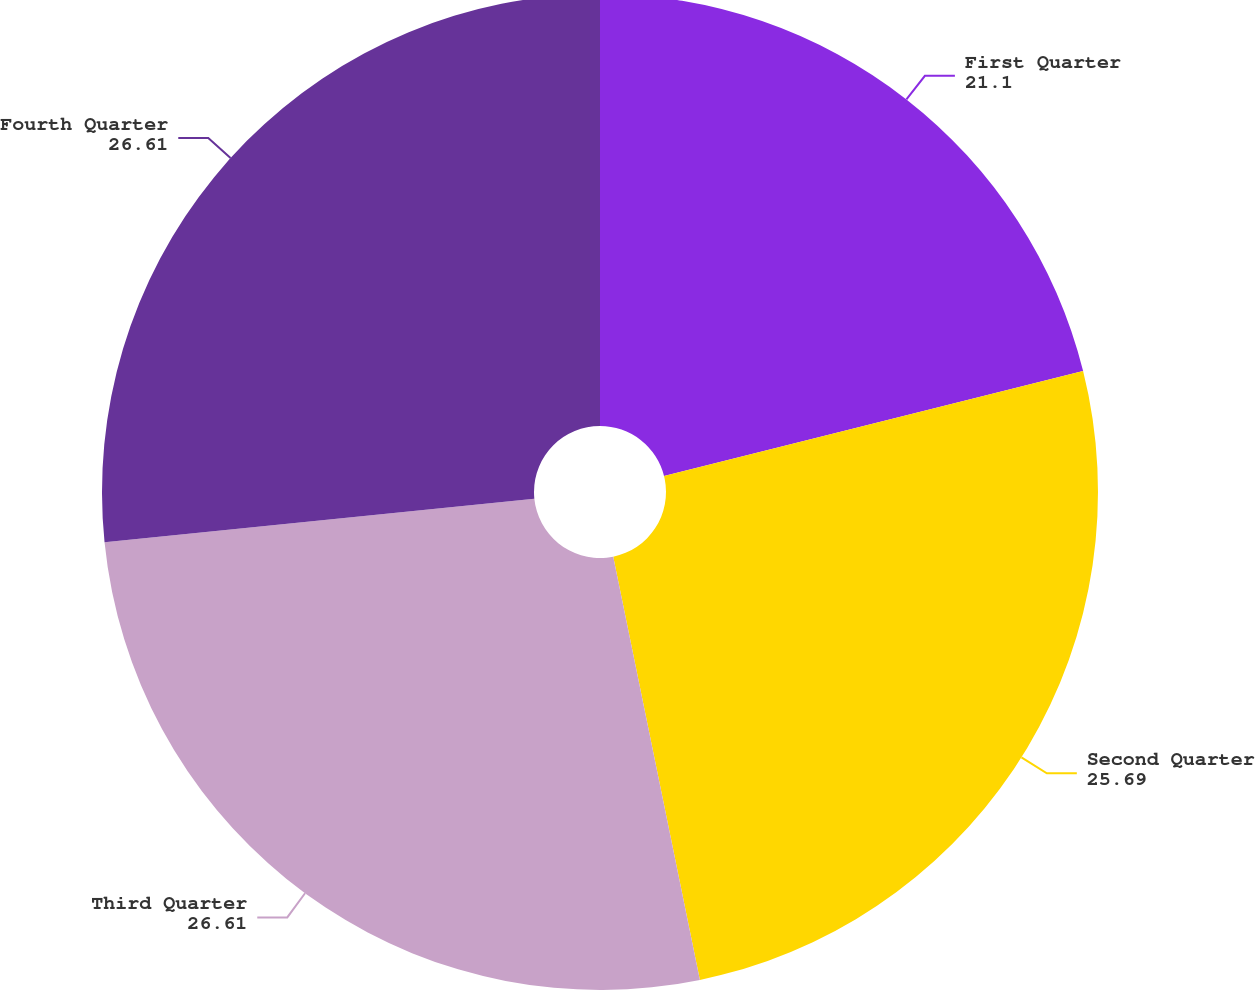Convert chart to OTSL. <chart><loc_0><loc_0><loc_500><loc_500><pie_chart><fcel>First Quarter<fcel>Second Quarter<fcel>Third Quarter<fcel>Fourth Quarter<nl><fcel>21.1%<fcel>25.69%<fcel>26.61%<fcel>26.61%<nl></chart> 